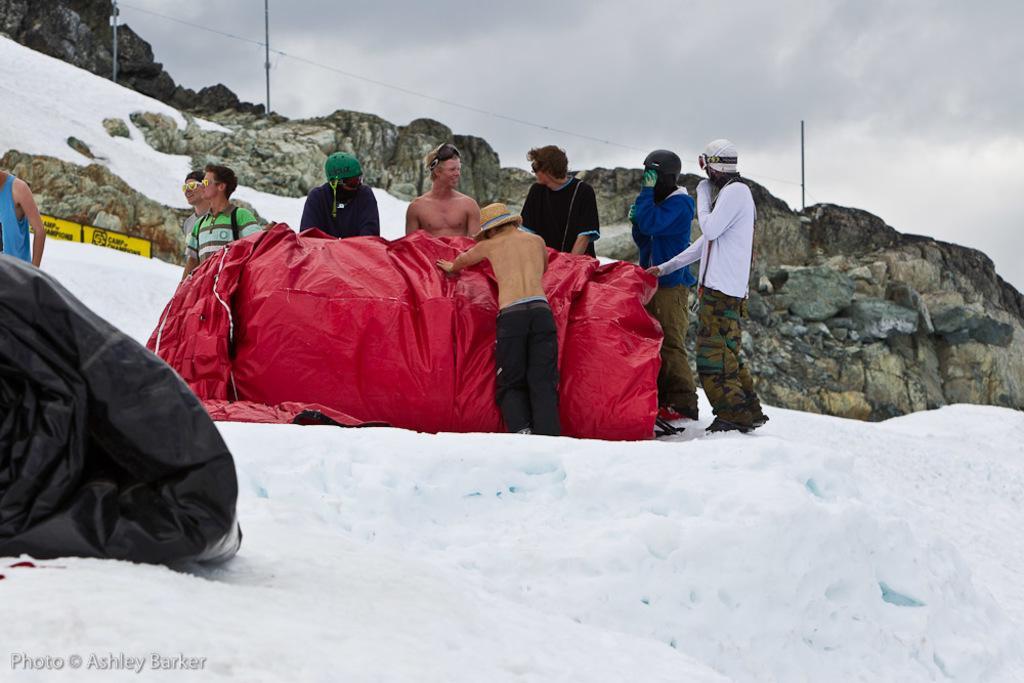Describe this image in one or two sentences. In this image, in the middle, we can see a group of people standing in front of a red color cloth. On the left side, we can also see black color. In the background, we can see some rocks, poles and a wire. At the top, we can see a sky, at the bottom, we can see a snow. 